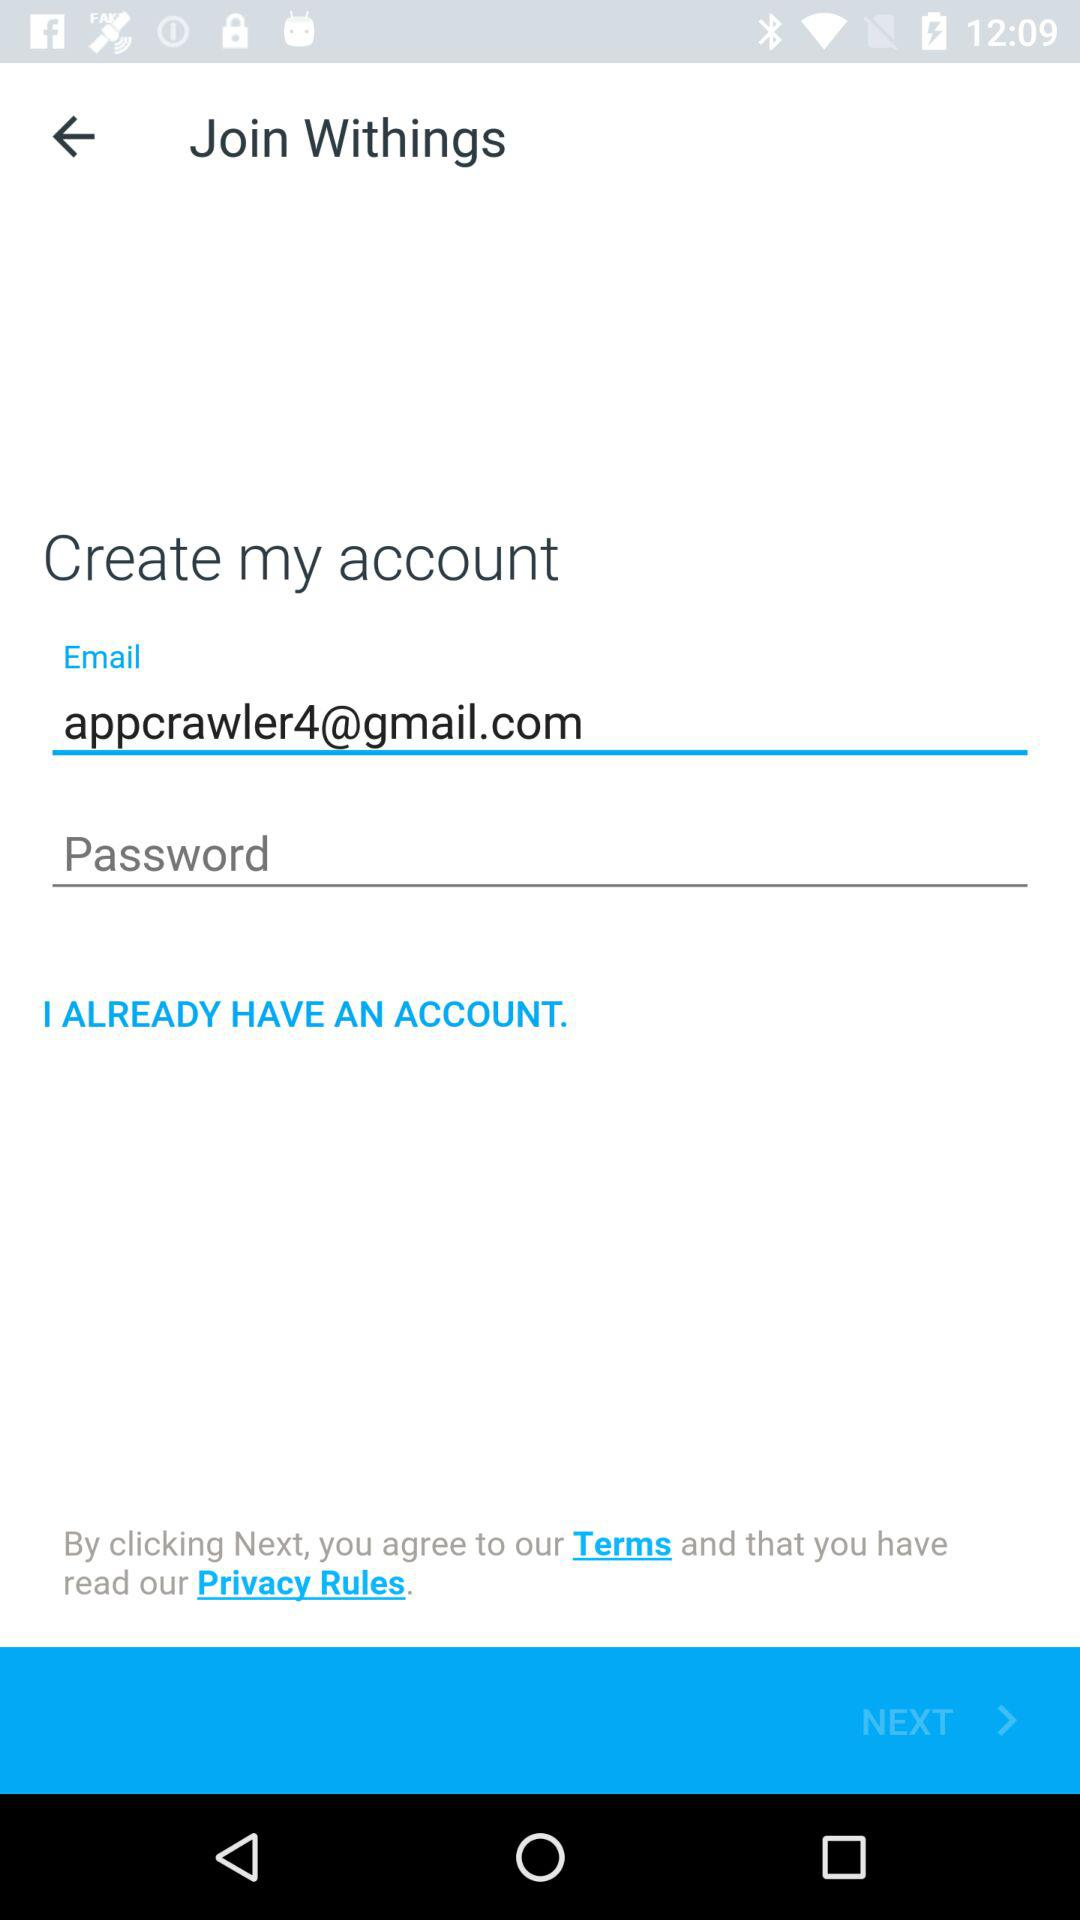What is the name of the user?
When the provided information is insufficient, respond with <no answer>. <no answer> 